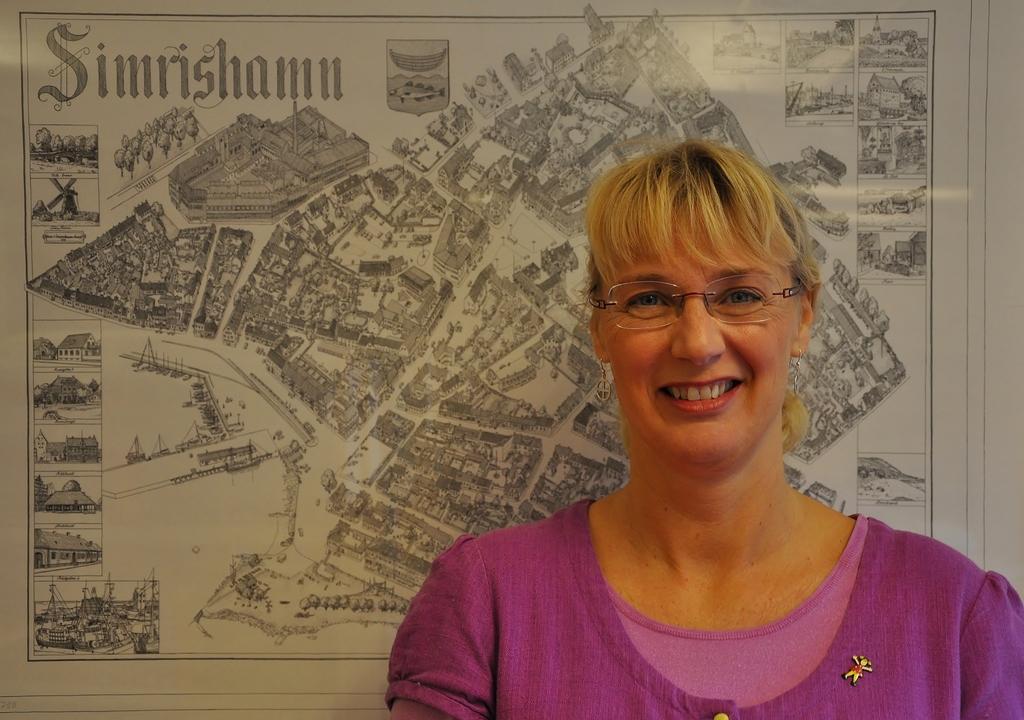Could you give a brief overview of what you see in this image? In this picture there is a woman with pink dress is standing and smiling. At the back there is a poster on the wall and there are pictures of buildings and trees and there is text on the poster. 